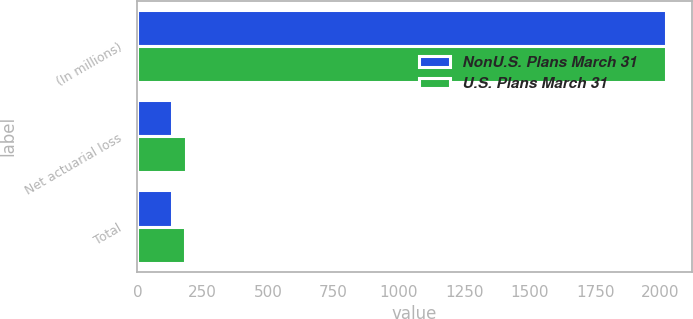Convert chart. <chart><loc_0><loc_0><loc_500><loc_500><stacked_bar_chart><ecel><fcel>(In millions)<fcel>Net actuarial loss<fcel>Total<nl><fcel>NonU.S. Plans March 31<fcel>2019<fcel>133<fcel>133<nl><fcel>U.S. Plans March 31<fcel>2019<fcel>186<fcel>182<nl></chart> 